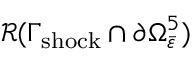<formula> <loc_0><loc_0><loc_500><loc_500>\mathcal { R } ( \Gamma _ { s h o c k } \cap \partial \Omega _ { \bar { \varepsilon } } ^ { 5 } )</formula> 